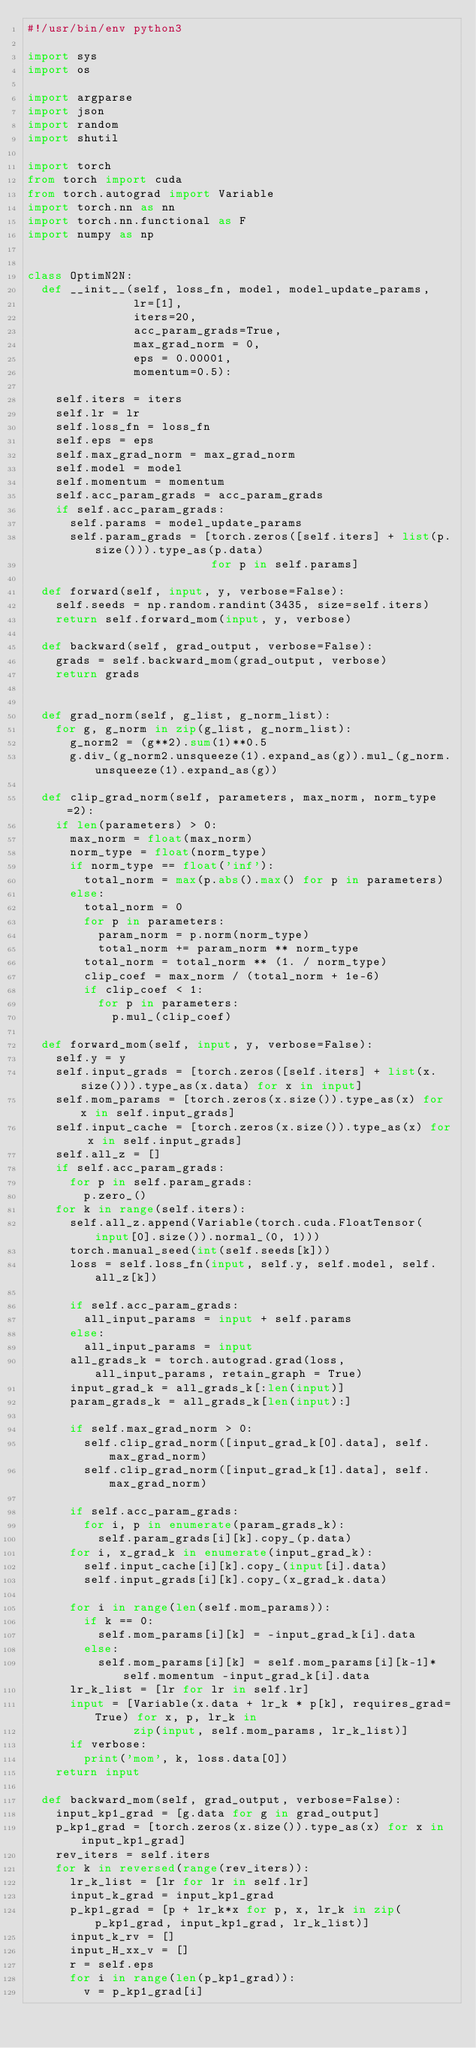<code> <loc_0><loc_0><loc_500><loc_500><_Python_>#!/usr/bin/env python3

import sys
import os

import argparse
import json
import random
import shutil

import torch
from torch import cuda
from torch.autograd import Variable
import torch.nn as nn
import torch.nn.functional as F
import numpy as np


class OptimN2N:
  def __init__(self, loss_fn, model, model_update_params,
               lr=[1],
               iters=20,
               acc_param_grads=True,
               max_grad_norm = 0,
               eps = 0.00001,
               momentum=0.5):
       
    self.iters = iters
    self.lr = lr
    self.loss_fn = loss_fn
    self.eps = eps
    self.max_grad_norm = max_grad_norm
    self.model = model
    self.momentum = momentum
    self.acc_param_grads = acc_param_grads
    if self.acc_param_grads:
      self.params = model_update_params
      self.param_grads = [torch.zeros([self.iters] + list(p.size())).type_as(p.data)
                          for p in self.params]
    
  def forward(self, input, y, verbose=False):
    self.seeds = np.random.randint(3435, size=self.iters)
    return self.forward_mom(input, y, verbose)

  def backward(self, grad_output, verbose=False):
    grads = self.backward_mom(grad_output, verbose)
    return grads                             

      
  def grad_norm(self, g_list, g_norm_list):
    for g, g_norm in zip(g_list, g_norm_list):
      g_norm2 = (g**2).sum(1)**0.5
      g.div_(g_norm2.unsqueeze(1).expand_as(g)).mul_(g_norm.unsqueeze(1).expand_as(g))
      
  def clip_grad_norm(self, parameters, max_norm, norm_type=2):
    if len(parameters) > 0:
      max_norm = float(max_norm)
      norm_type = float(norm_type)
      if norm_type == float('inf'):
        total_norm = max(p.abs().max() for p in parameters)
      else:
        total_norm = 0
        for p in parameters:
          param_norm = p.norm(norm_type)
          total_norm += param_norm ** norm_type
        total_norm = total_norm ** (1. / norm_type)
        clip_coef = max_norm / (total_norm + 1e-6)
        if clip_coef < 1:
          for p in parameters:
            p.mul_(clip_coef)
            
  def forward_mom(self, input, y, verbose=False):
    self.y = y
    self.input_grads = [torch.zeros([self.iters] + list(x.size())).type_as(x.data) for x in input]
    self.mom_params = [torch.zeros(x.size()).type_as(x) for x in self.input_grads]    
    self.input_cache = [torch.zeros(x.size()).type_as(x) for x in self.input_grads]
    self.all_z = []    
    if self.acc_param_grads:
      for p in self.param_grads:
        p.zero_()
    for k in range(self.iters):
      self.all_z.append(Variable(torch.cuda.FloatTensor(input[0].size()).normal_(0, 1)))
      torch.manual_seed(int(self.seeds[k]))
      loss = self.loss_fn(input, self.y, self.model, self.all_z[k])
        
      if self.acc_param_grads:
        all_input_params = input + self.params
      else:
        all_input_params = input        
      all_grads_k = torch.autograd.grad(loss, all_input_params, retain_graph = True)
      input_grad_k = all_grads_k[:len(input)]
      param_grads_k = all_grads_k[len(input):]
      
      if self.max_grad_norm > 0:        
        self.clip_grad_norm([input_grad_k[0].data], self.max_grad_norm)
        self.clip_grad_norm([input_grad_k[1].data], self.max_grad_norm)
        
      if self.acc_param_grads:
        for i, p in enumerate(param_grads_k):
          self.param_grads[i][k].copy_(p.data)
      for i, x_grad_k in enumerate(input_grad_k):
        self.input_cache[i][k].copy_(input[i].data)        
        self.input_grads[i][k].copy_(x_grad_k.data)        
        
      for i in range(len(self.mom_params)):
        if k == 0:
          self.mom_params[i][k] = -input_grad_k[i].data
        else:
          self.mom_params[i][k] = self.mom_params[i][k-1]*self.momentum -input_grad_k[i].data
      lr_k_list = [lr for lr in self.lr]
      input = [Variable(x.data + lr_k * p[k], requires_grad=True) for x, p, lr_k in
               zip(input, self.mom_params, lr_k_list)]      
      if verbose:
        print('mom', k, loss.data[0])
    return input

  def backward_mom(self, grad_output, verbose=False):
    input_kp1_grad = [g.data for g in grad_output]
    p_kp1_grad = [torch.zeros(x.size()).type_as(x) for x in input_kp1_grad]
    rev_iters = self.iters
    for k in reversed(range(rev_iters)):
      lr_k_list = [lr for lr in self.lr]
      input_k_grad = input_kp1_grad
      p_kp1_grad = [p + lr_k*x for p, x, lr_k in zip(p_kp1_grad, input_kp1_grad, lr_k_list)]
      input_k_rv = []
      input_H_xx_v = []
      r = self.eps
      for i in range(len(p_kp1_grad)):
        v = p_kp1_grad[i]</code> 